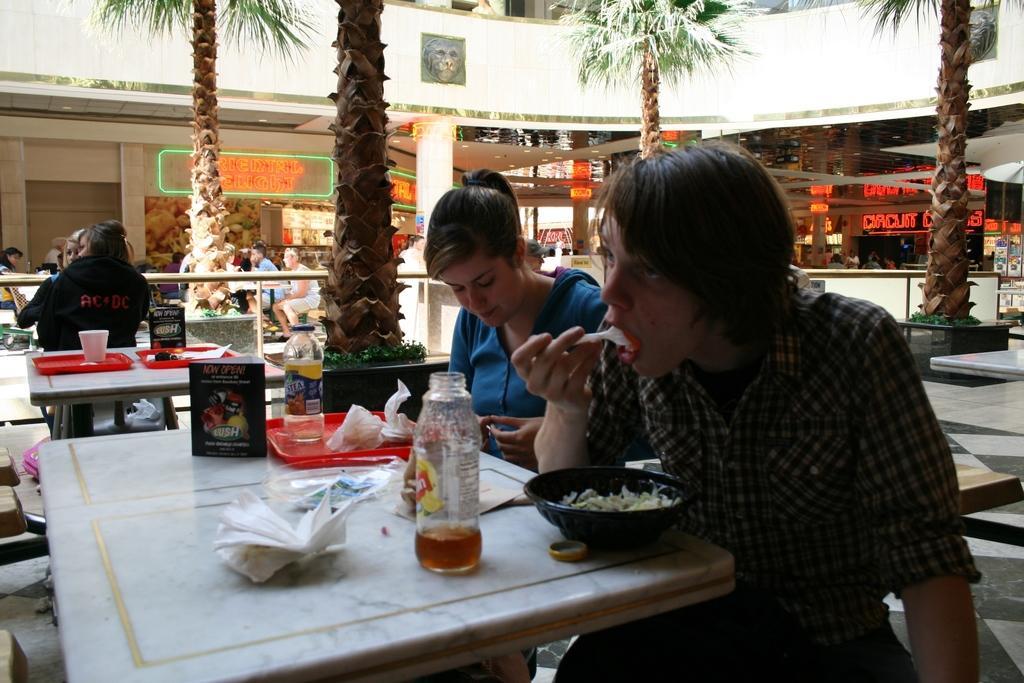Can you describe this image briefly? In the image we can see there are people who are sitting on chair and on table there is bowl in which there is food, juice bottle, napkins and at the back there are trees. 